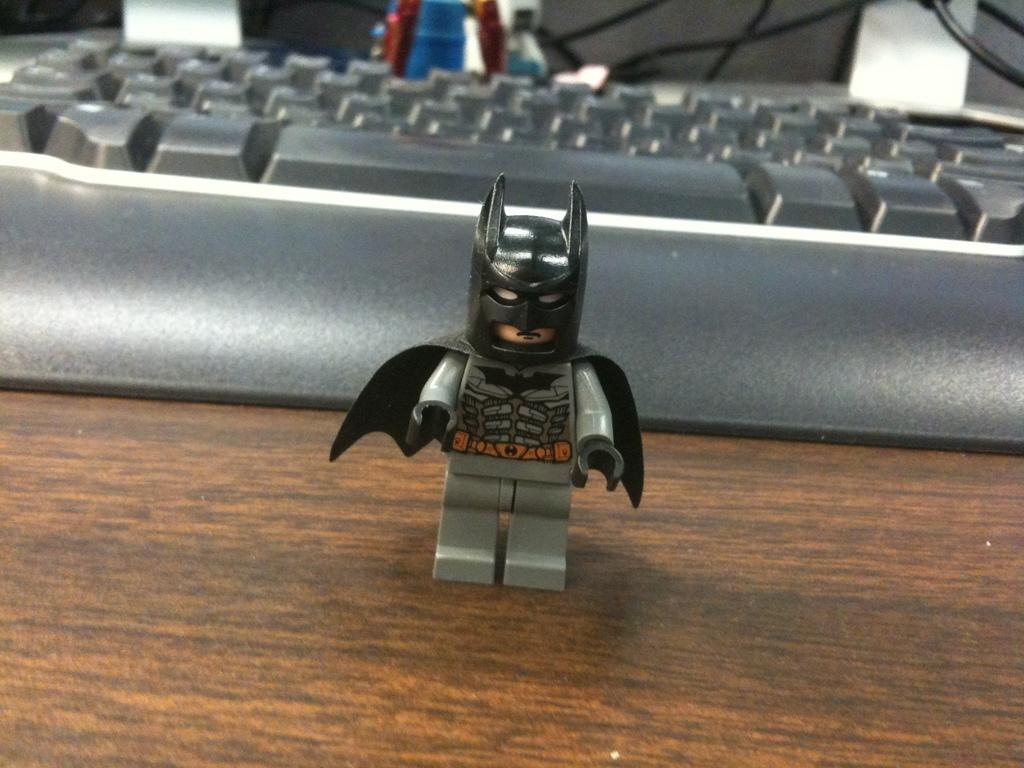What type of furniture is present in the image? There is a table in the image. What can be seen on top of the table? There is a toy and a keyboard on the table. What else is present on the table? There are cables and other objects on the table. Where is the shelf located in the image? There is no shelf present in the image. Can you see a basketball on the table in the image? There is no basketball present in the image. 